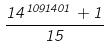<formula> <loc_0><loc_0><loc_500><loc_500>\frac { 1 4 ^ { 1 0 9 1 4 0 1 } + 1 } { 1 5 }</formula> 